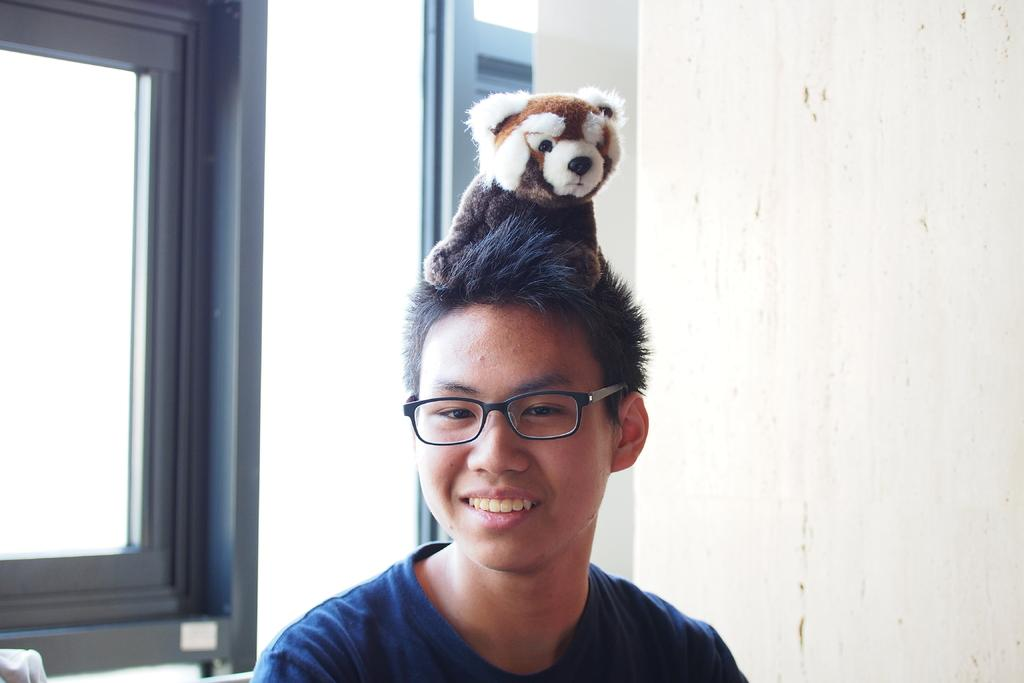Who is present in the image? There is a man in the picture. What is the man doing in the image? The man is holding a doll on his head. What can be seen in the background of the picture? There is a wall in the background of the picture. Where is the window located in the image? There is a window on the right side of the picture. What type of lace can be seen on the man's clothing in the image? There is no lace visible on the man's clothing in the image. Can you tell me how many people are helping the man in the image? There is no indication of anyone helping the man in the image; he is holding the doll on his head alone. 